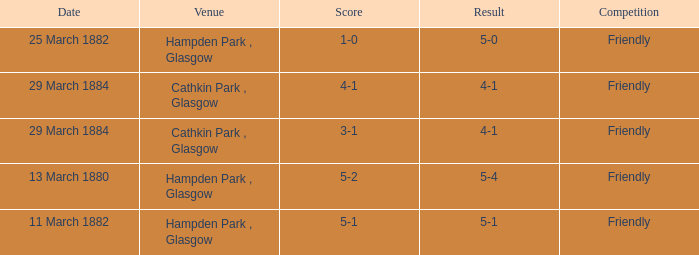Which competition had a 4-1 result, and a score of 4-1? Friendly. 